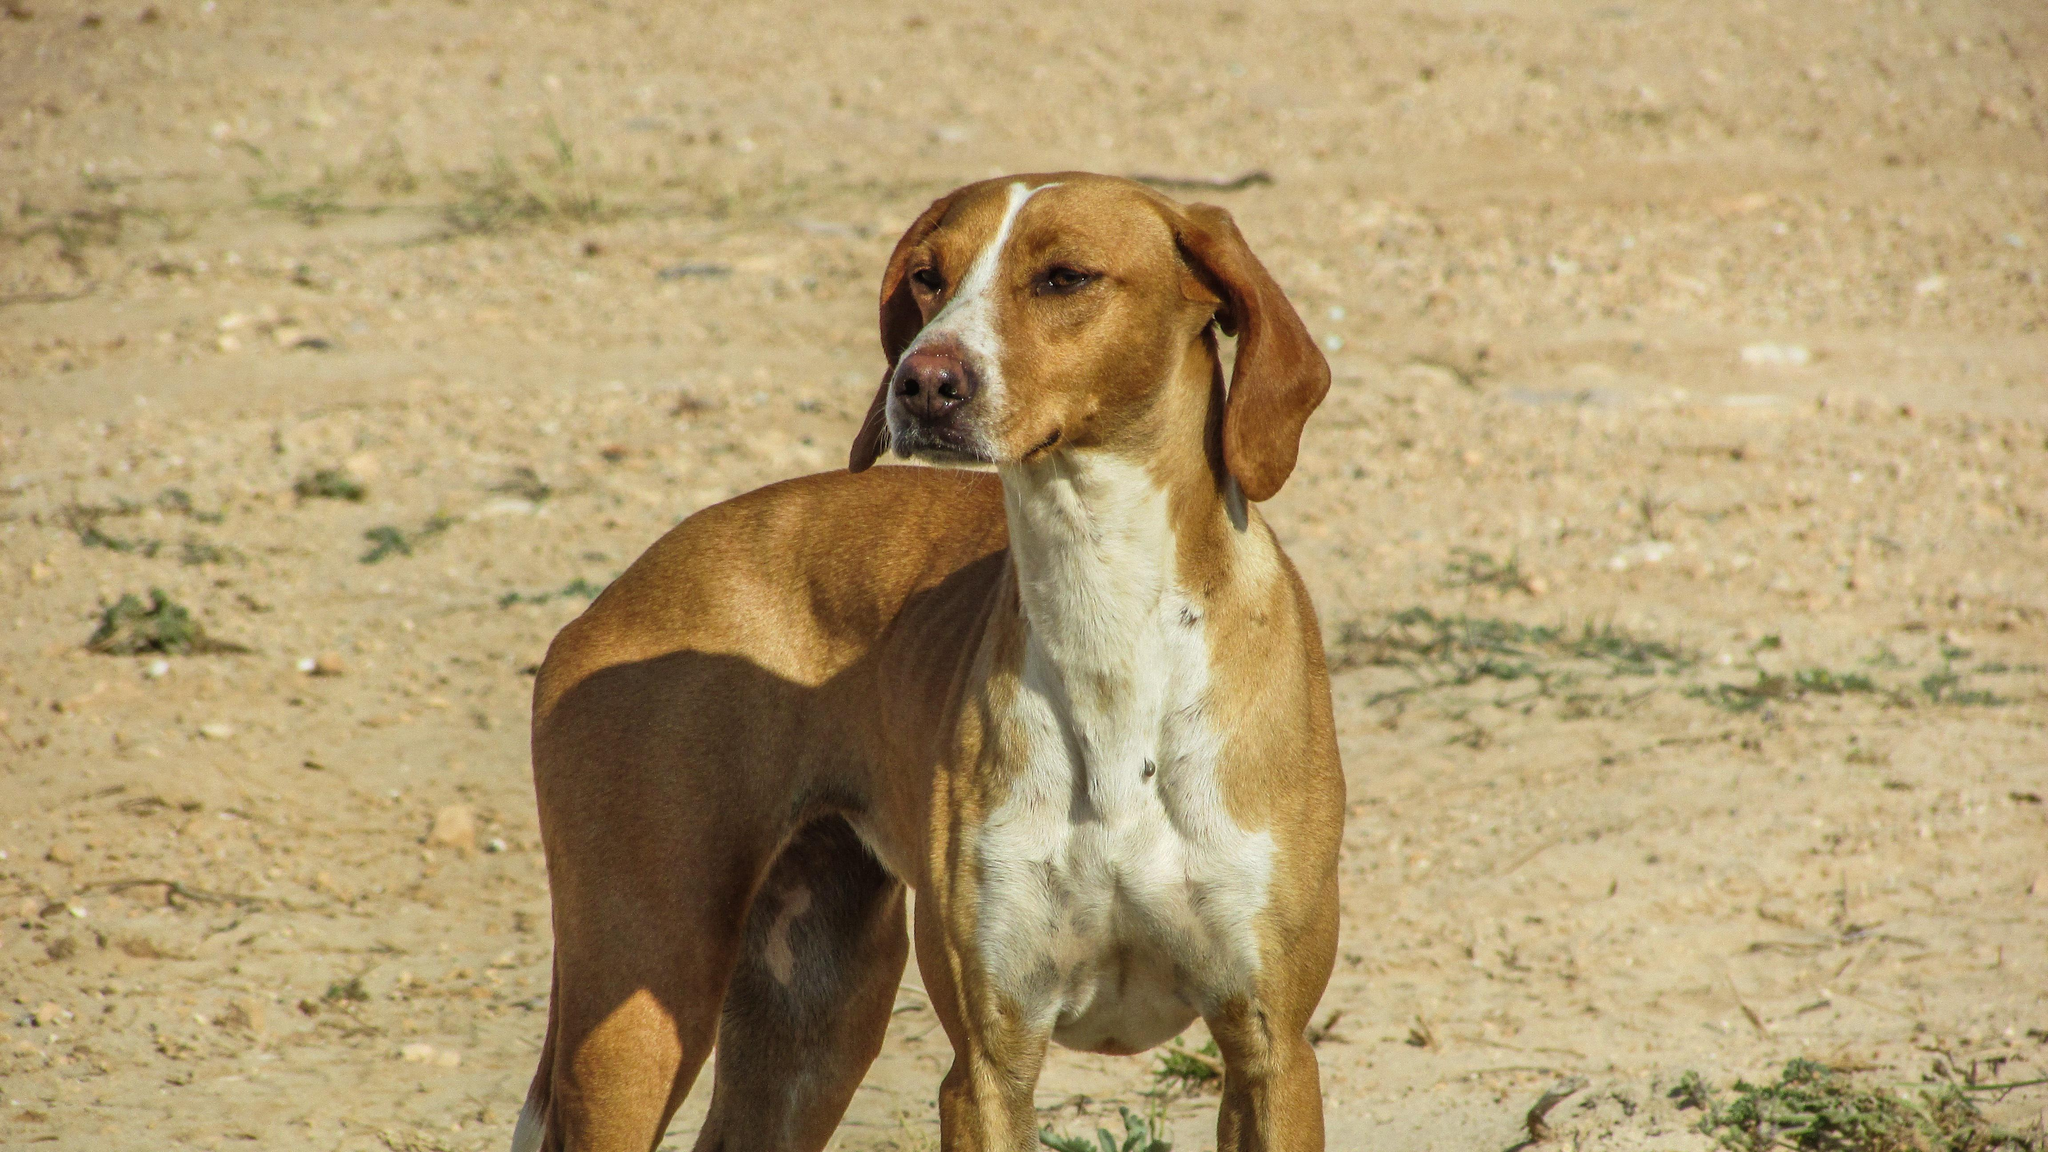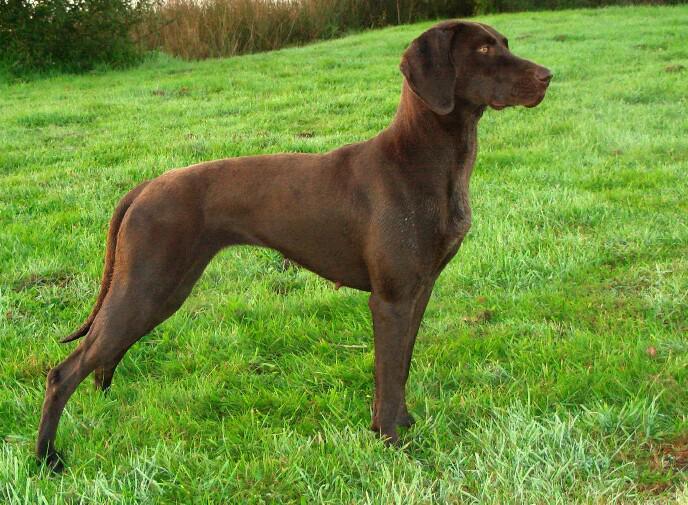The first image is the image on the left, the second image is the image on the right. Analyze the images presented: Is the assertion "The dog on the left is gazing leftward, and the dog on the right stands in profile with its body turned rightward." valid? Answer yes or no. Yes. The first image is the image on the left, the second image is the image on the right. Analyze the images presented: Is the assertion "At least one dog is sitting." valid? Answer yes or no. No. 